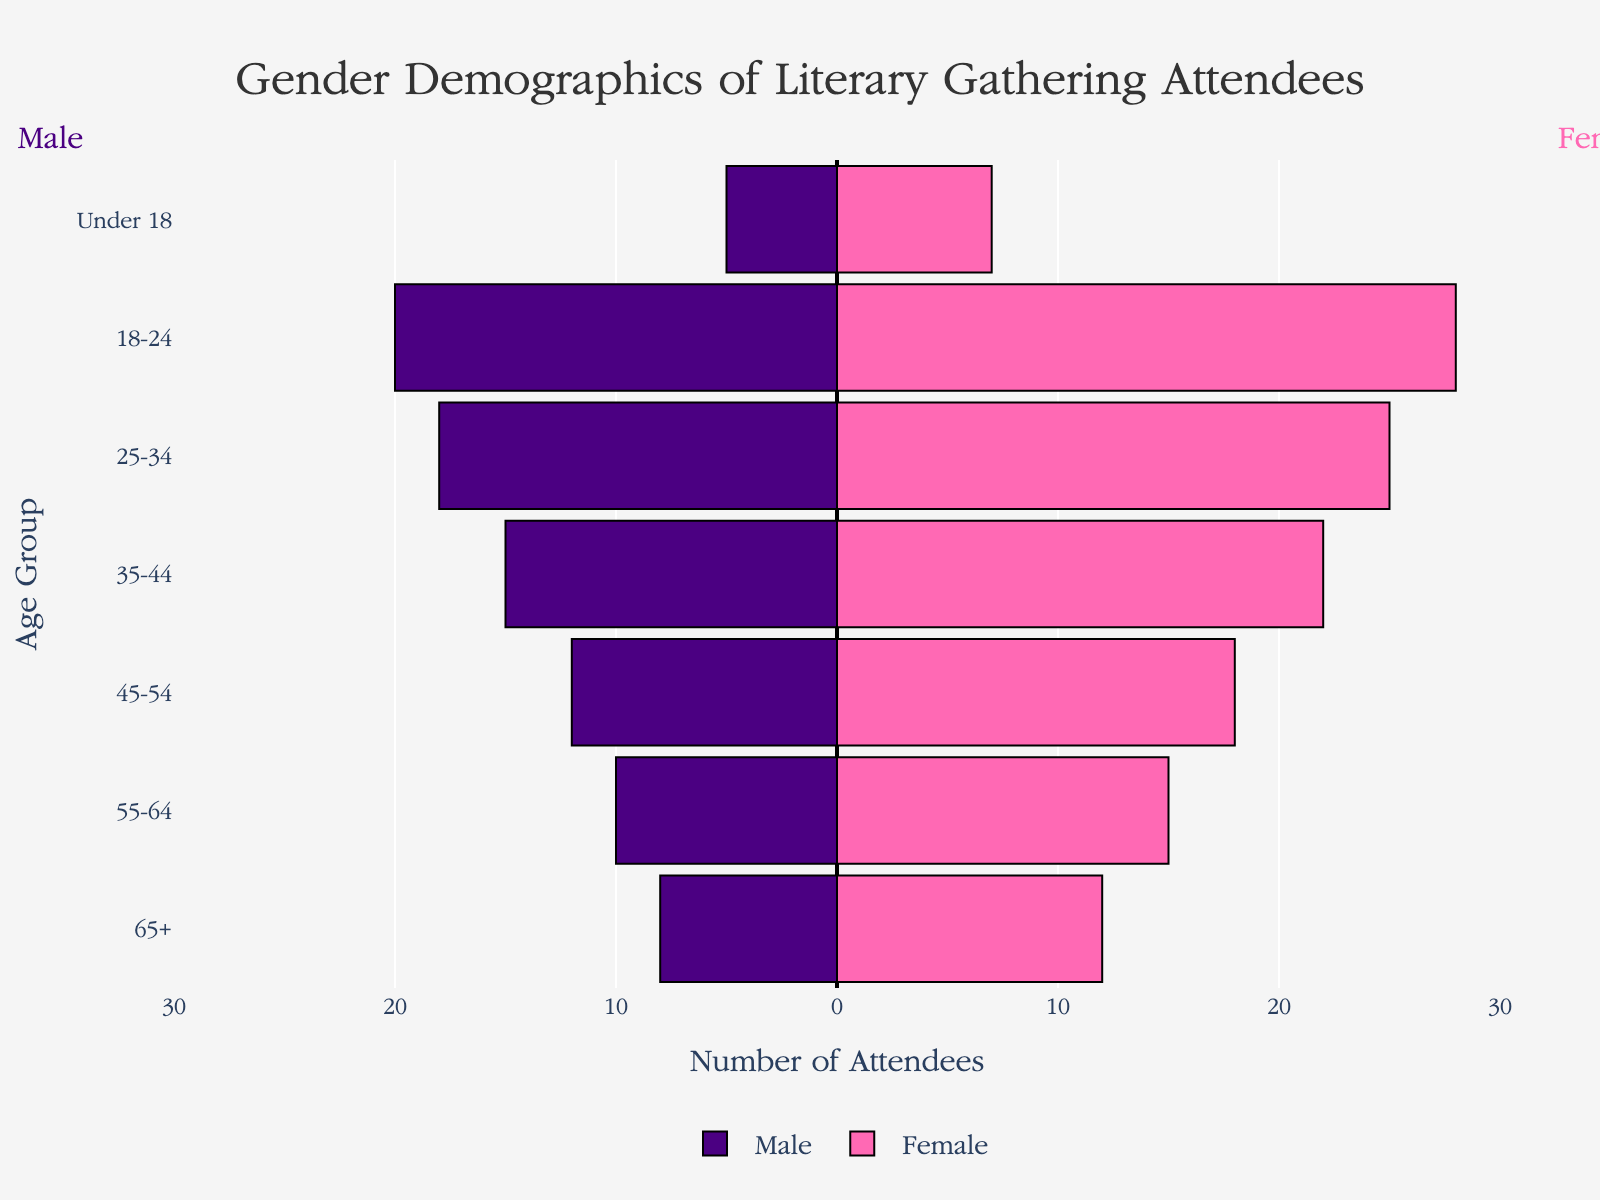Which age group has the highest number of female attendees? Look at the bar lengths for female attendees across age groups. The bar for the '18-24' bracket is the longest, indicating the highest number of female attendees.
Answer: 18-24 Which age group has the lowest number of male attendees? Observe the lengths of the male-attendee bars. The 'Under 18' group shows the shortest bar, indicating the fewest male attendees.
Answer: Under 18 What is the total number of attendees aged 45-54? Add the number of male and female attendees in the 45-54 age group. Male attendees are 12, and female attendees are 18. Sum them to get the total.
Answer: 30 How many more females are there than males in the 35-44 age group? Subtract the number of male attendees from female attendees in the 35-44 age group. Females are 22, and males are 15.
Answer: 7 Combing the total number of attendees under 18 and aged 65+, which group has more attendees? Add the number of male and female attendees in both 'Under 18' and '65+' groups. Under 18: 5 (male) + 7 (female) = 12. 65+: 8 (male) + 12 (female) = 20. Compare both sums.
Answer: 65+ Which age group has the most balanced gender ratio? Compare the differences between male and female attendees across all age groups. The smallest difference indicates the most balanced ratio.
Answer: 55-64 What is the ratio of male to female attendees in the 18-24 age group? The number of male attendees is 20, and the number of female attendees is 28. Divide male attendees by female attendees to get the ratio.
Answer: 20:28 or 5:7 In which age group is the gender disparity the greatest? Look for the age group with the largest difference between the number of males and females.
Answer: 18-24 Across all age groups, are there more male or female attendees in total? Sum the male and female attendees across all age groups and compare the totals.
Answer: Female 